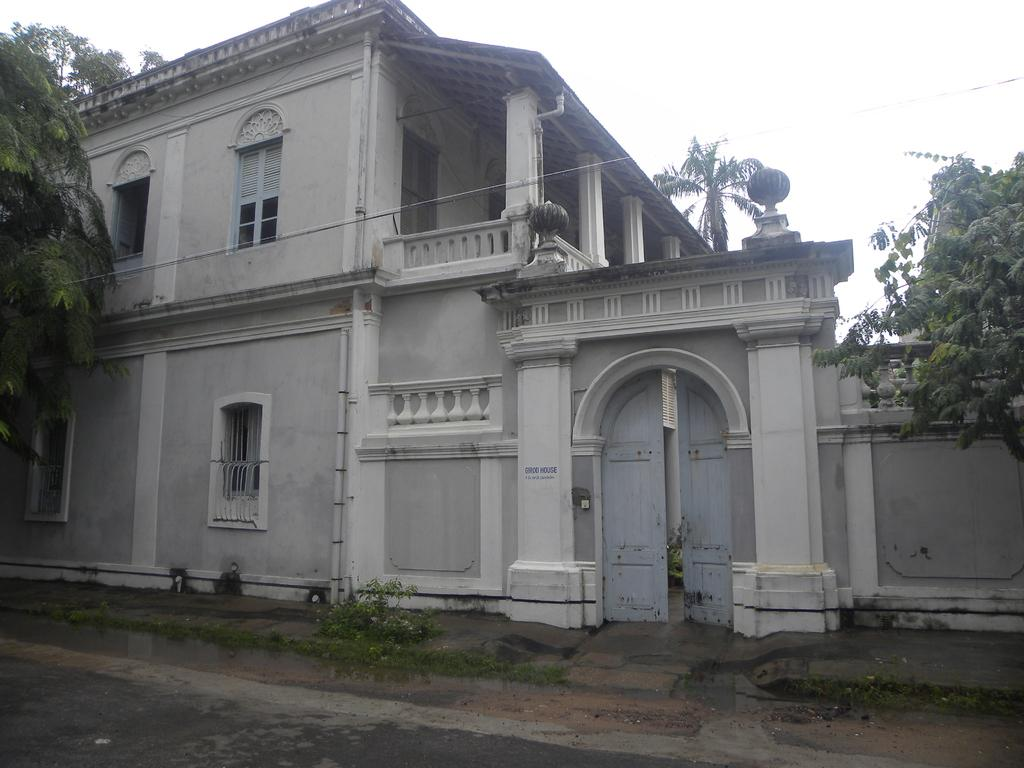What is the main structure in the center of the image? There is a building in the center of the image. What type of natural elements can be seen in the image? There are trees in the image. What architectural features are present on the building? There are doors and windows in the image. What else can be seen in the image besides the building and trees? There are wires in the image. What is visible at the top of the image? The sky is visible at the top of the image. What is visible at the bottom of the image? There is a road visible at the bottom of the image. How many tomatoes are hanging from the wires in the image? There are no tomatoes present in the image; only wires can be seen. What type of toy is being played with on the road in the image? There is no toy present in the image; only a road can be seen at the bottom of the image. 